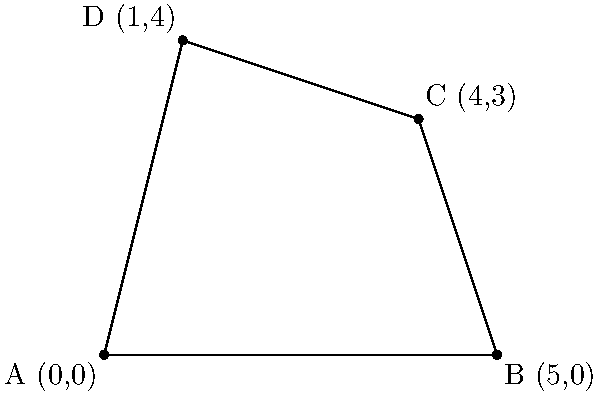A sustainable manufacturing facility is planned on a plot of land with the following coordinate points: A(0,0), B(5,0), C(4,3), and D(1,4). Calculate the area of this irregularly shaped plot to determine if it meets the minimum space requirements for the facility. Round your answer to the nearest whole number. To calculate the area of this irregular quadrilateral, we can use the Shoelace formula (also known as the surveyor's formula). The steps are as follows:

1) The Shoelace formula for a quadrilateral with vertices $(x_1, y_1)$, $(x_2, y_2)$, $(x_3, y_3)$, and $(x_4, y_4)$ is:

   $$Area = \frac{1}{2}|x_1y_2 + x_2y_3 + x_3y_4 + x_4y_1 - y_1x_2 - y_2x_3 - y_3x_4 - y_4x_1|$$

2) Substitute the given coordinates:
   A(0,0), B(5,0), C(4,3), D(1,4)

3) Apply the formula:

   $$Area = \frac{1}{2}|(0 \cdot 0 + 5 \cdot 3 + 4 \cdot 4 + 1 \cdot 0) - (0 \cdot 5 + 0 \cdot 4 + 3 \cdot 1 + 4 \cdot 0)|$$

4) Simplify:

   $$Area = \frac{1}{2}|(0 + 15 + 16 + 0) - (0 + 0 + 3 + 0)|$$
   $$Area = \frac{1}{2}|31 - 3|$$
   $$Area = \frac{1}{2} \cdot 28 = 14$$

5) The exact area is 14 square units.

6) Rounding to the nearest whole number: 14 square units.
Answer: 14 square units 